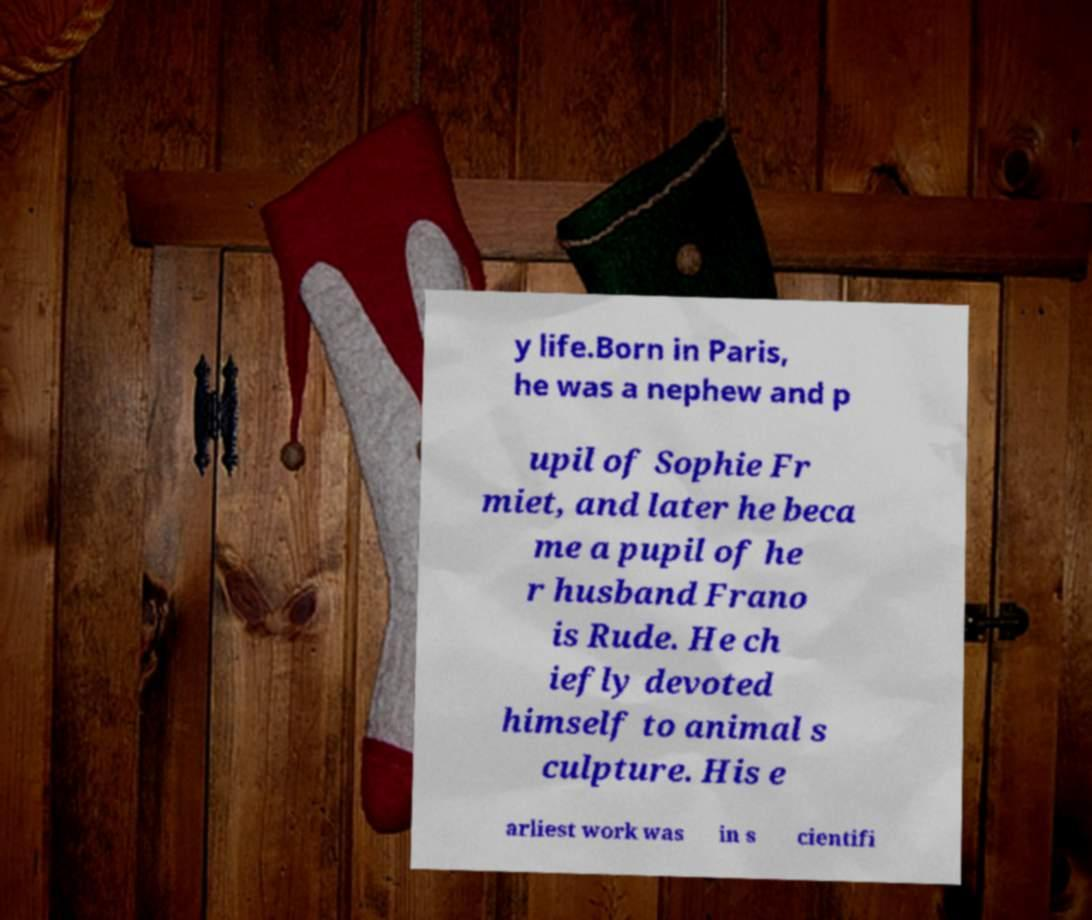Please identify and transcribe the text found in this image. y life.Born in Paris, he was a nephew and p upil of Sophie Fr miet, and later he beca me a pupil of he r husband Frano is Rude. He ch iefly devoted himself to animal s culpture. His e arliest work was in s cientifi 